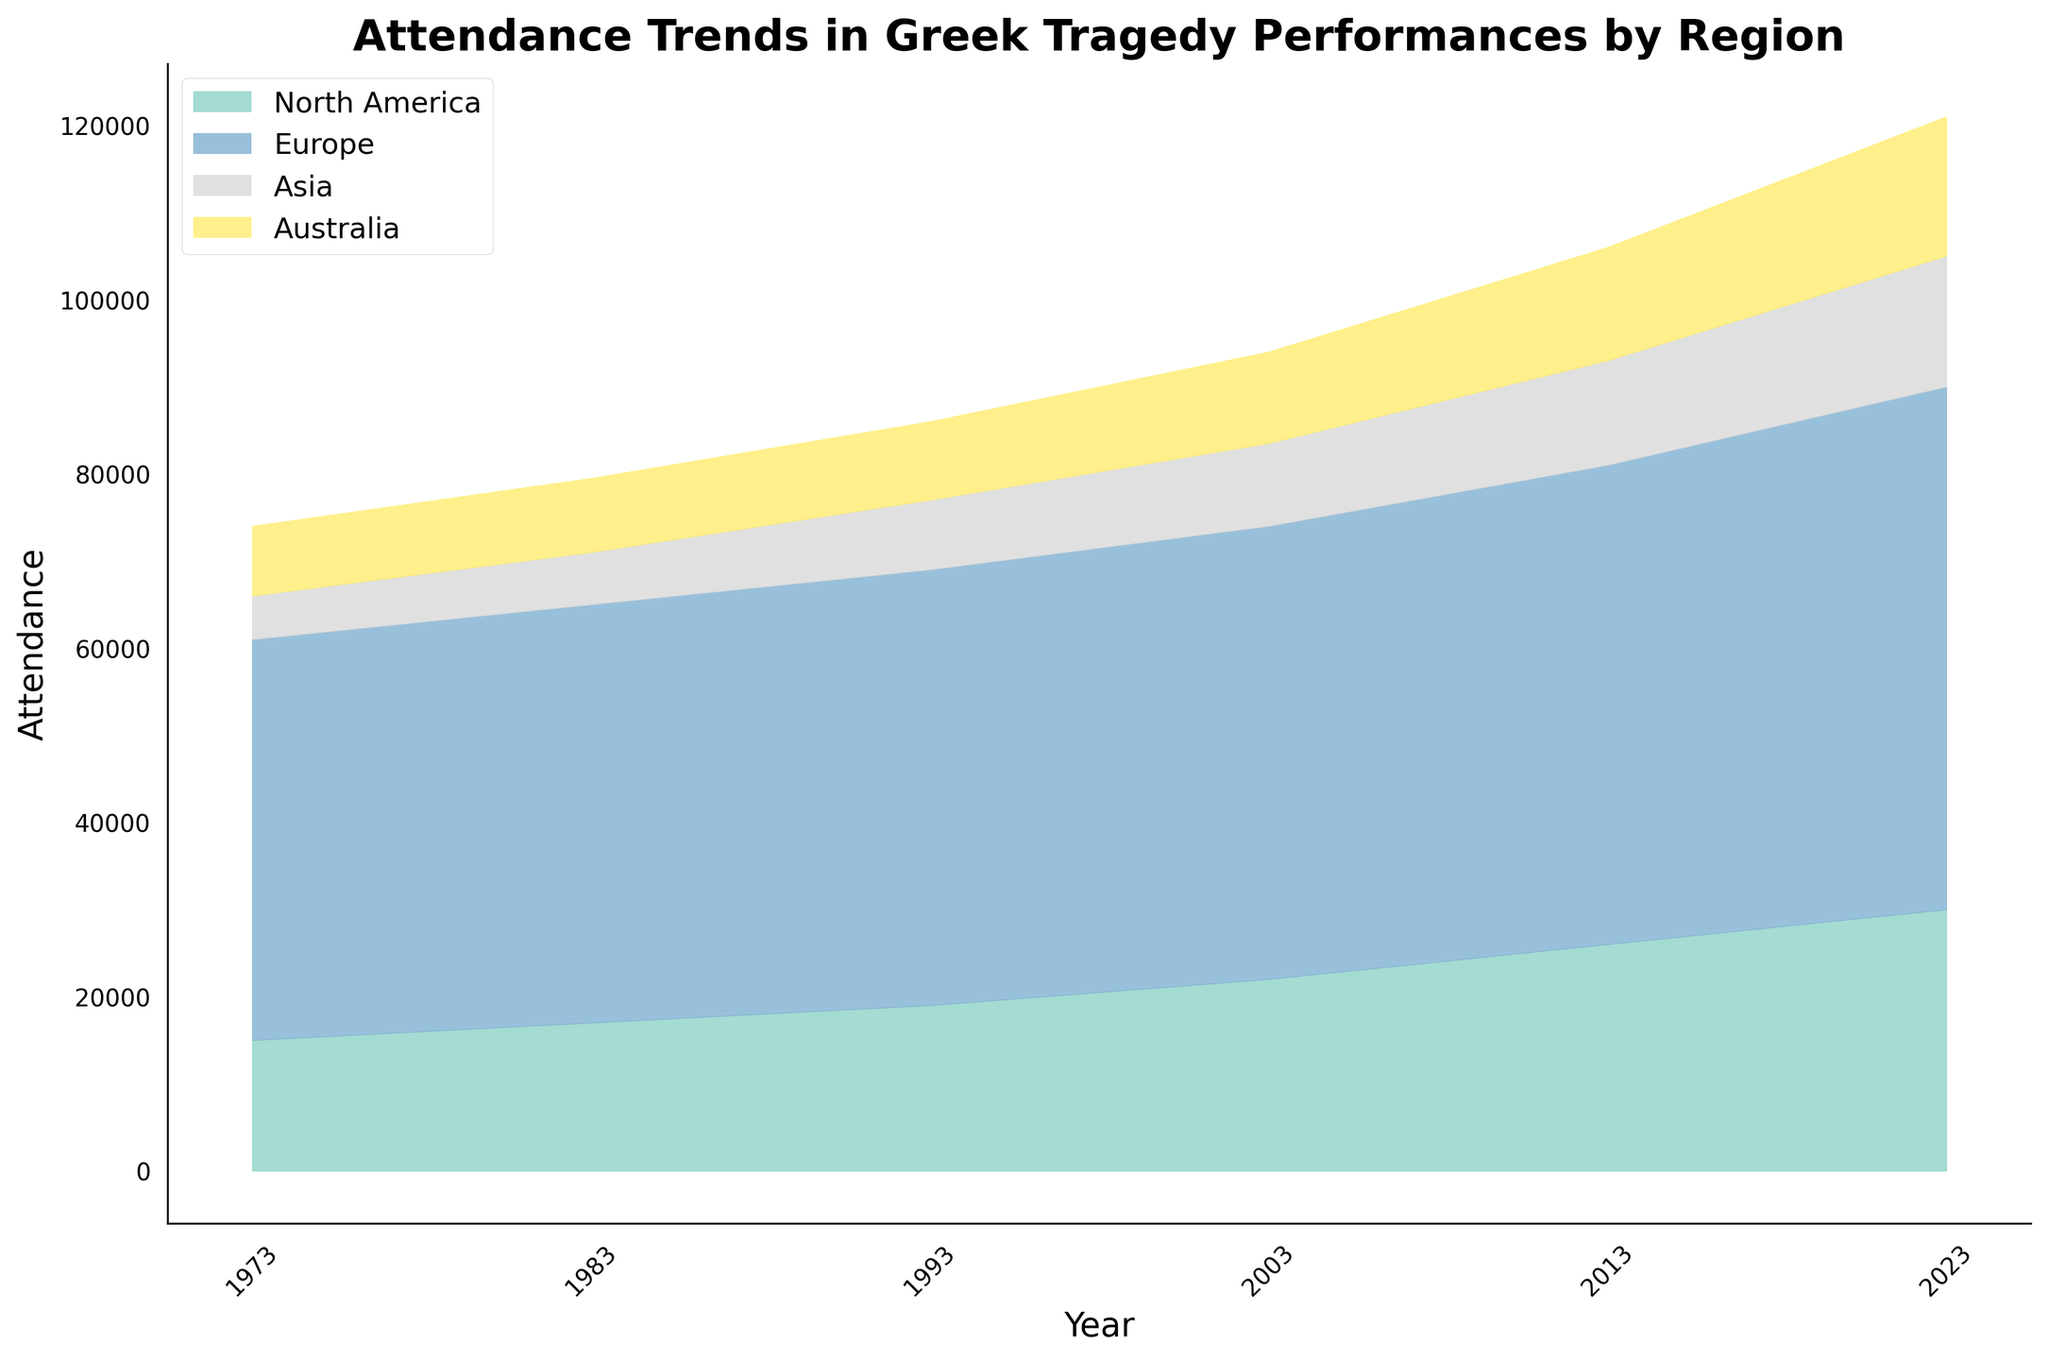What's the title of the figure? Look at the top of the figure to read the main heading which provides a summary of what the plot represents.
Answer: Attendance Trends in Greek Tragedy Performances by Region How many regions are displayed in the figure? Each colored section represents a different region. Count the different color segments in the legend.
Answer: Four Which region had the highest attendance in 1983, and what was the attendance number? Observe the segments corresponding to each region in 1983, and identify the one with the highest vertical extent. Look at the legend to find the respective region and check the attendance value.
Answer: Europe, 48,000 What is the overall trend in attendance for North America over the years? Track the North America segment over the timeline from 1973 to 2023 and note whether the attendance is increasing, decreasing, or stable.
Answer: Increasing Compare the attendance trends of Asia and Australia in the past 50 years. Which region showed a higher growth rate? Examine the attendance segments for Asia and Australia from 1973 to 2023 and compare how each has grown over time.
Answer: Australia During which decade did Europe have its largest increase in attendance? Observe the changes in the Europe segment for each decade (1973, 1983, etc.). Note the differences in the attendance values between consecutive decades and find the largest increase.
Answer: 2013-2023 What's the cumulative attendance for all regions in the year 2023? Add the attendance numbers for all regions for the year 2023 to get the total attendance.
Answer: 121,000 How does the attendance in North America in 1973 compare to that in Asia in 2023? Check the attendance values for North America in 1973 and compare them with the attendance values for Asia in 2023.
Answer: North America in 1973: 15,000, Asia in 2023: 15,000. They are equal Which region had the lowest attendance in 1993, and what was the number? Identify the segment with the lowest height for the year 1993, then check the legend to find which region it corresponds to and look at the attendance value.
Answer: Asia, 8,000 What percentage of the total attendance in 2013 was from Europe? Calculate the total attendance for 2013, then find the attendance for Europe in 2013. Divide the Europe attendance by the total and multiply by 100 to get the percentage.
Answer: (55,000 / (26,000 + 55,000 + 12,000 + 13,000)) * 100 ≈ 55% 